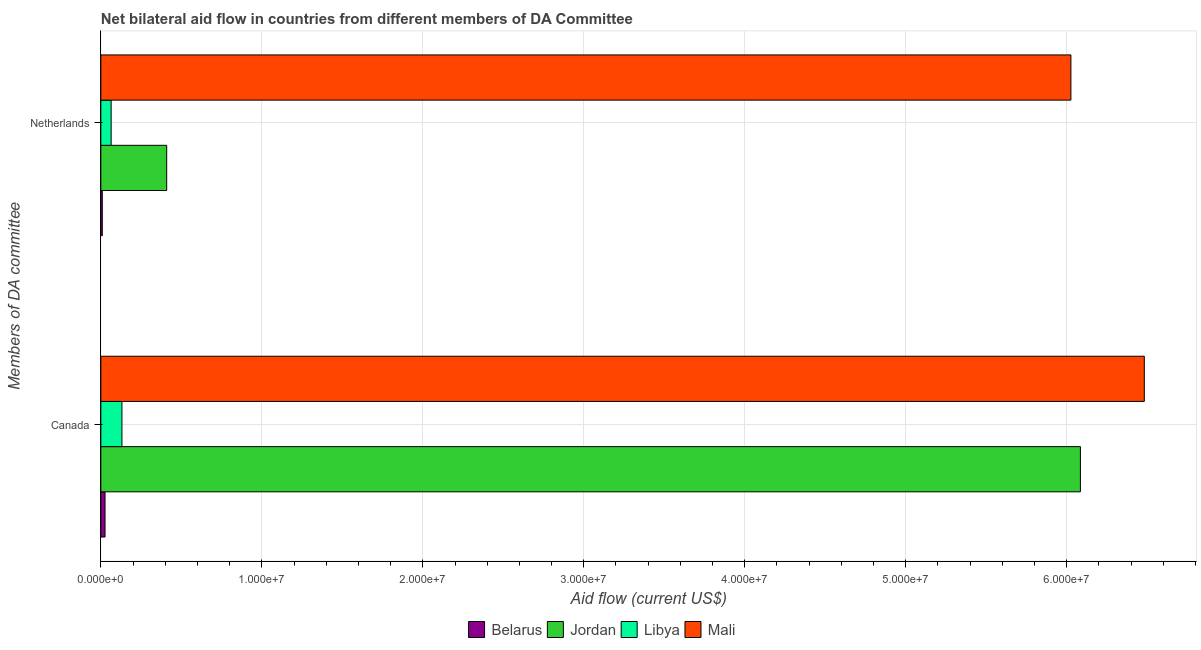How many different coloured bars are there?
Offer a very short reply. 4. What is the amount of aid given by canada in Belarus?
Provide a short and direct response. 2.60e+05. Across all countries, what is the maximum amount of aid given by netherlands?
Your answer should be very brief. 6.03e+07. Across all countries, what is the minimum amount of aid given by canada?
Your answer should be very brief. 2.60e+05. In which country was the amount of aid given by netherlands maximum?
Provide a short and direct response. Mali. In which country was the amount of aid given by canada minimum?
Your response must be concise. Belarus. What is the total amount of aid given by netherlands in the graph?
Provide a succinct answer. 6.51e+07. What is the difference between the amount of aid given by netherlands in Libya and that in Mali?
Give a very brief answer. -5.96e+07. What is the difference between the amount of aid given by netherlands in Jordan and the amount of aid given by canada in Mali?
Provide a succinct answer. -6.07e+07. What is the average amount of aid given by canada per country?
Ensure brevity in your answer.  3.18e+07. What is the difference between the amount of aid given by canada and amount of aid given by netherlands in Mali?
Make the answer very short. 4.56e+06. In how many countries, is the amount of aid given by canada greater than 40000000 US$?
Your answer should be very brief. 2. What is the ratio of the amount of aid given by canada in Mali to that in Jordan?
Keep it short and to the point. 1.07. What does the 4th bar from the top in Netherlands represents?
Your answer should be compact. Belarus. What does the 2nd bar from the bottom in Netherlands represents?
Your answer should be very brief. Jordan. Are all the bars in the graph horizontal?
Provide a short and direct response. Yes. Does the graph contain any zero values?
Your answer should be compact. No. Where does the legend appear in the graph?
Ensure brevity in your answer.  Bottom center. How many legend labels are there?
Give a very brief answer. 4. What is the title of the graph?
Provide a succinct answer. Net bilateral aid flow in countries from different members of DA Committee. Does "Suriname" appear as one of the legend labels in the graph?
Keep it short and to the point. No. What is the label or title of the X-axis?
Your response must be concise. Aid flow (current US$). What is the label or title of the Y-axis?
Your answer should be compact. Members of DA committee. What is the Aid flow (current US$) in Belarus in Canada?
Offer a very short reply. 2.60e+05. What is the Aid flow (current US$) in Jordan in Canada?
Ensure brevity in your answer.  6.08e+07. What is the Aid flow (current US$) in Libya in Canada?
Offer a terse response. 1.31e+06. What is the Aid flow (current US$) of Mali in Canada?
Your answer should be very brief. 6.48e+07. What is the Aid flow (current US$) of Jordan in Netherlands?
Keep it short and to the point. 4.09e+06. What is the Aid flow (current US$) in Libya in Netherlands?
Ensure brevity in your answer.  6.40e+05. What is the Aid flow (current US$) of Mali in Netherlands?
Keep it short and to the point. 6.03e+07. Across all Members of DA committee, what is the maximum Aid flow (current US$) of Jordan?
Your answer should be compact. 6.08e+07. Across all Members of DA committee, what is the maximum Aid flow (current US$) in Libya?
Give a very brief answer. 1.31e+06. Across all Members of DA committee, what is the maximum Aid flow (current US$) in Mali?
Keep it short and to the point. 6.48e+07. Across all Members of DA committee, what is the minimum Aid flow (current US$) of Jordan?
Offer a terse response. 4.09e+06. Across all Members of DA committee, what is the minimum Aid flow (current US$) of Libya?
Make the answer very short. 6.40e+05. Across all Members of DA committee, what is the minimum Aid flow (current US$) in Mali?
Your answer should be very brief. 6.03e+07. What is the total Aid flow (current US$) of Jordan in the graph?
Your response must be concise. 6.49e+07. What is the total Aid flow (current US$) of Libya in the graph?
Ensure brevity in your answer.  1.95e+06. What is the total Aid flow (current US$) of Mali in the graph?
Provide a short and direct response. 1.25e+08. What is the difference between the Aid flow (current US$) of Jordan in Canada and that in Netherlands?
Provide a succinct answer. 5.68e+07. What is the difference between the Aid flow (current US$) in Libya in Canada and that in Netherlands?
Offer a very short reply. 6.70e+05. What is the difference between the Aid flow (current US$) of Mali in Canada and that in Netherlands?
Keep it short and to the point. 4.56e+06. What is the difference between the Aid flow (current US$) of Belarus in Canada and the Aid flow (current US$) of Jordan in Netherlands?
Offer a terse response. -3.83e+06. What is the difference between the Aid flow (current US$) in Belarus in Canada and the Aid flow (current US$) in Libya in Netherlands?
Your answer should be very brief. -3.80e+05. What is the difference between the Aid flow (current US$) of Belarus in Canada and the Aid flow (current US$) of Mali in Netherlands?
Offer a terse response. -6.00e+07. What is the difference between the Aid flow (current US$) of Jordan in Canada and the Aid flow (current US$) of Libya in Netherlands?
Provide a short and direct response. 6.02e+07. What is the difference between the Aid flow (current US$) in Jordan in Canada and the Aid flow (current US$) in Mali in Netherlands?
Offer a terse response. 5.90e+05. What is the difference between the Aid flow (current US$) in Libya in Canada and the Aid flow (current US$) in Mali in Netherlands?
Provide a succinct answer. -5.90e+07. What is the average Aid flow (current US$) of Belarus per Members of DA committee?
Give a very brief answer. 1.75e+05. What is the average Aid flow (current US$) in Jordan per Members of DA committee?
Ensure brevity in your answer.  3.25e+07. What is the average Aid flow (current US$) of Libya per Members of DA committee?
Keep it short and to the point. 9.75e+05. What is the average Aid flow (current US$) in Mali per Members of DA committee?
Your response must be concise. 6.25e+07. What is the difference between the Aid flow (current US$) of Belarus and Aid flow (current US$) of Jordan in Canada?
Your response must be concise. -6.06e+07. What is the difference between the Aid flow (current US$) in Belarus and Aid flow (current US$) in Libya in Canada?
Offer a terse response. -1.05e+06. What is the difference between the Aid flow (current US$) in Belarus and Aid flow (current US$) in Mali in Canada?
Your answer should be compact. -6.46e+07. What is the difference between the Aid flow (current US$) of Jordan and Aid flow (current US$) of Libya in Canada?
Offer a very short reply. 5.95e+07. What is the difference between the Aid flow (current US$) of Jordan and Aid flow (current US$) of Mali in Canada?
Provide a succinct answer. -3.97e+06. What is the difference between the Aid flow (current US$) of Libya and Aid flow (current US$) of Mali in Canada?
Give a very brief answer. -6.35e+07. What is the difference between the Aid flow (current US$) in Belarus and Aid flow (current US$) in Libya in Netherlands?
Give a very brief answer. -5.50e+05. What is the difference between the Aid flow (current US$) in Belarus and Aid flow (current US$) in Mali in Netherlands?
Make the answer very short. -6.02e+07. What is the difference between the Aid flow (current US$) in Jordan and Aid flow (current US$) in Libya in Netherlands?
Keep it short and to the point. 3.45e+06. What is the difference between the Aid flow (current US$) of Jordan and Aid flow (current US$) of Mali in Netherlands?
Ensure brevity in your answer.  -5.62e+07. What is the difference between the Aid flow (current US$) of Libya and Aid flow (current US$) of Mali in Netherlands?
Offer a terse response. -5.96e+07. What is the ratio of the Aid flow (current US$) of Belarus in Canada to that in Netherlands?
Provide a short and direct response. 2.89. What is the ratio of the Aid flow (current US$) of Jordan in Canada to that in Netherlands?
Your answer should be compact. 14.88. What is the ratio of the Aid flow (current US$) in Libya in Canada to that in Netherlands?
Offer a terse response. 2.05. What is the ratio of the Aid flow (current US$) in Mali in Canada to that in Netherlands?
Ensure brevity in your answer.  1.08. What is the difference between the highest and the second highest Aid flow (current US$) in Belarus?
Offer a very short reply. 1.70e+05. What is the difference between the highest and the second highest Aid flow (current US$) of Jordan?
Your answer should be compact. 5.68e+07. What is the difference between the highest and the second highest Aid flow (current US$) of Libya?
Provide a short and direct response. 6.70e+05. What is the difference between the highest and the second highest Aid flow (current US$) in Mali?
Your answer should be very brief. 4.56e+06. What is the difference between the highest and the lowest Aid flow (current US$) of Jordan?
Provide a short and direct response. 5.68e+07. What is the difference between the highest and the lowest Aid flow (current US$) in Libya?
Your answer should be very brief. 6.70e+05. What is the difference between the highest and the lowest Aid flow (current US$) in Mali?
Make the answer very short. 4.56e+06. 